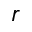<formula> <loc_0><loc_0><loc_500><loc_500>r</formula> 